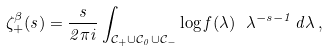<formula> <loc_0><loc_0><loc_500><loc_500>\zeta ^ { \beta } _ { + } ( s ) = \frac { s } { 2 \pi i } \int _ { \mathcal { C } _ { + } \cup \mathcal { C } _ { 0 } \cup \mathcal { C } _ { - } } \log { f ( \lambda ) } \ \lambda ^ { - s - 1 } \, d \lambda \, ,</formula> 